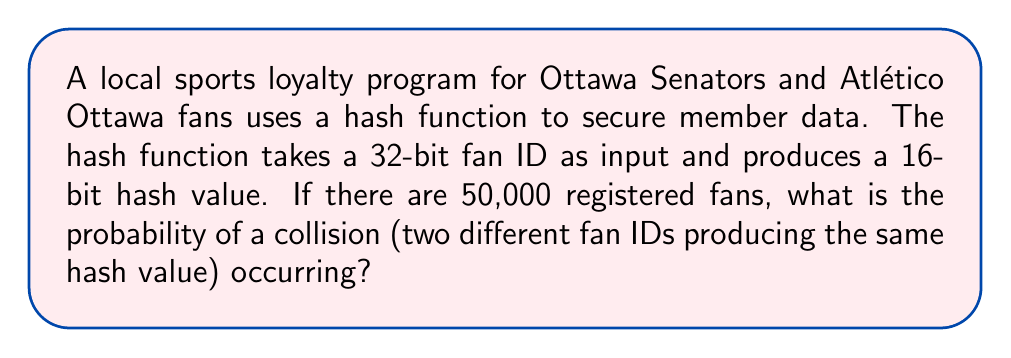Show me your answer to this math problem. To solve this problem, we'll use the birthday paradox principle and follow these steps:

1) First, we need to calculate the number of possible hash values:
   $$ 2^{16} = 65,536 $$

2) Next, we'll use the birthday paradox formula to calculate the probability of no collisions:
   $$ P(\text{no collision}) = \frac{65536!}{65536^{50000} \cdot (65536-50000)!} $$

3) However, this is difficult to calculate directly due to large numbers. We can approximate it using the exponential function:
   $$ P(\text{no collision}) \approx e^{-\frac{n(n-1)}{2m}} $$
   Where $n$ is the number of fans (50,000) and $m$ is the number of possible hash values (65,536).

4) Plugging in our values:
   $$ P(\text{no collision}) \approx e^{-\frac{50000(49999)}{2 \cdot 65536}} \approx e^{-19073.95} \approx 0 $$

5) Therefore, the probability of a collision is:
   $$ P(\text{collision}) = 1 - P(\text{no collision}) \approx 1 - 0 = 1 $$

This means a collision is virtually certain to occur with these parameters.
Answer: $\approx 1$ (or 99.99%) 